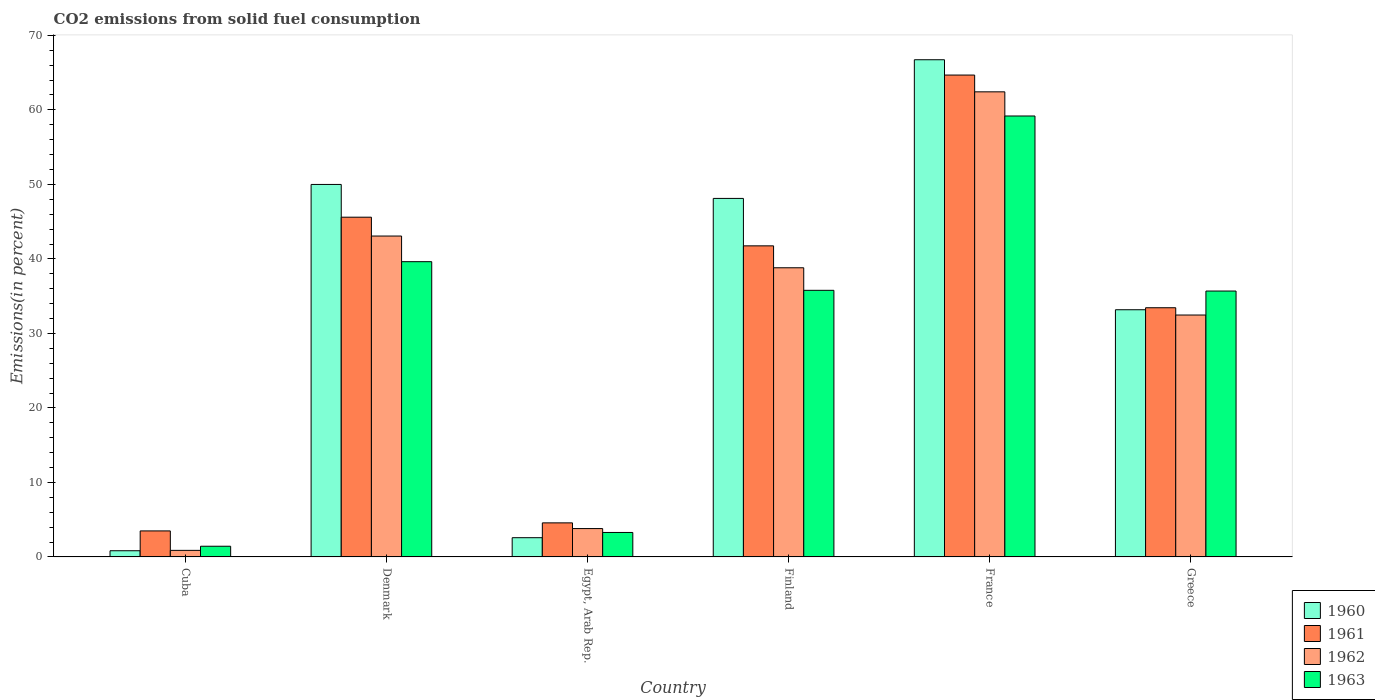How many different coloured bars are there?
Provide a succinct answer. 4. Are the number of bars on each tick of the X-axis equal?
Your response must be concise. Yes. How many bars are there on the 6th tick from the right?
Your answer should be compact. 4. What is the label of the 2nd group of bars from the left?
Your answer should be compact. Denmark. What is the total CO2 emitted in 1962 in Finland?
Make the answer very short. 38.81. Across all countries, what is the maximum total CO2 emitted in 1961?
Keep it short and to the point. 64.68. Across all countries, what is the minimum total CO2 emitted in 1961?
Provide a short and direct response. 3.49. In which country was the total CO2 emitted in 1961 maximum?
Give a very brief answer. France. In which country was the total CO2 emitted in 1963 minimum?
Your response must be concise. Cuba. What is the total total CO2 emitted in 1961 in the graph?
Keep it short and to the point. 193.53. What is the difference between the total CO2 emitted in 1960 in Finland and that in France?
Give a very brief answer. -18.61. What is the difference between the total CO2 emitted in 1963 in France and the total CO2 emitted in 1960 in Finland?
Ensure brevity in your answer.  11.06. What is the average total CO2 emitted in 1963 per country?
Give a very brief answer. 29.17. What is the difference between the total CO2 emitted of/in 1960 and total CO2 emitted of/in 1963 in Egypt, Arab Rep.?
Your answer should be very brief. -0.7. In how many countries, is the total CO2 emitted in 1963 greater than 44 %?
Give a very brief answer. 1. What is the ratio of the total CO2 emitted in 1961 in Cuba to that in Finland?
Your response must be concise. 0.08. What is the difference between the highest and the second highest total CO2 emitted in 1963?
Provide a short and direct response. -23.4. What is the difference between the highest and the lowest total CO2 emitted in 1962?
Offer a terse response. 61.54. In how many countries, is the total CO2 emitted in 1960 greater than the average total CO2 emitted in 1960 taken over all countries?
Ensure brevity in your answer.  3. Is the sum of the total CO2 emitted in 1963 in Finland and France greater than the maximum total CO2 emitted in 1960 across all countries?
Make the answer very short. Yes. How many bars are there?
Keep it short and to the point. 24. Does the graph contain any zero values?
Keep it short and to the point. No. Does the graph contain grids?
Offer a terse response. No. How many legend labels are there?
Your response must be concise. 4. How are the legend labels stacked?
Offer a terse response. Vertical. What is the title of the graph?
Provide a succinct answer. CO2 emissions from solid fuel consumption. Does "1964" appear as one of the legend labels in the graph?
Your answer should be very brief. No. What is the label or title of the Y-axis?
Give a very brief answer. Emissions(in percent). What is the Emissions(in percent) in 1960 in Cuba?
Ensure brevity in your answer.  0.83. What is the Emissions(in percent) of 1961 in Cuba?
Provide a succinct answer. 3.49. What is the Emissions(in percent) of 1962 in Cuba?
Keep it short and to the point. 0.88. What is the Emissions(in percent) in 1963 in Cuba?
Your answer should be compact. 1.43. What is the Emissions(in percent) in 1960 in Denmark?
Your answer should be compact. 49.99. What is the Emissions(in percent) of 1961 in Denmark?
Give a very brief answer. 45.6. What is the Emissions(in percent) in 1962 in Denmark?
Ensure brevity in your answer.  43.07. What is the Emissions(in percent) in 1963 in Denmark?
Your answer should be compact. 39.63. What is the Emissions(in percent) in 1960 in Egypt, Arab Rep.?
Give a very brief answer. 2.58. What is the Emissions(in percent) of 1961 in Egypt, Arab Rep.?
Offer a terse response. 4.57. What is the Emissions(in percent) in 1962 in Egypt, Arab Rep.?
Give a very brief answer. 3.81. What is the Emissions(in percent) in 1963 in Egypt, Arab Rep.?
Offer a terse response. 3.28. What is the Emissions(in percent) of 1960 in Finland?
Give a very brief answer. 48.12. What is the Emissions(in percent) of 1961 in Finland?
Make the answer very short. 41.75. What is the Emissions(in percent) of 1962 in Finland?
Offer a terse response. 38.81. What is the Emissions(in percent) in 1963 in Finland?
Give a very brief answer. 35.78. What is the Emissions(in percent) of 1960 in France?
Provide a short and direct response. 66.73. What is the Emissions(in percent) of 1961 in France?
Keep it short and to the point. 64.68. What is the Emissions(in percent) in 1962 in France?
Offer a very short reply. 62.42. What is the Emissions(in percent) in 1963 in France?
Provide a succinct answer. 59.18. What is the Emissions(in percent) in 1960 in Greece?
Provide a short and direct response. 33.18. What is the Emissions(in percent) in 1961 in Greece?
Provide a succinct answer. 33.45. What is the Emissions(in percent) in 1962 in Greece?
Offer a very short reply. 32.47. What is the Emissions(in percent) of 1963 in Greece?
Provide a short and direct response. 35.69. Across all countries, what is the maximum Emissions(in percent) of 1960?
Give a very brief answer. 66.73. Across all countries, what is the maximum Emissions(in percent) of 1961?
Offer a very short reply. 64.68. Across all countries, what is the maximum Emissions(in percent) of 1962?
Provide a succinct answer. 62.42. Across all countries, what is the maximum Emissions(in percent) of 1963?
Provide a succinct answer. 59.18. Across all countries, what is the minimum Emissions(in percent) in 1960?
Make the answer very short. 0.83. Across all countries, what is the minimum Emissions(in percent) in 1961?
Make the answer very short. 3.49. Across all countries, what is the minimum Emissions(in percent) of 1962?
Offer a terse response. 0.88. Across all countries, what is the minimum Emissions(in percent) of 1963?
Ensure brevity in your answer.  1.43. What is the total Emissions(in percent) of 1960 in the graph?
Make the answer very short. 201.43. What is the total Emissions(in percent) of 1961 in the graph?
Keep it short and to the point. 193.53. What is the total Emissions(in percent) in 1962 in the graph?
Your answer should be very brief. 181.45. What is the total Emissions(in percent) in 1963 in the graph?
Ensure brevity in your answer.  175. What is the difference between the Emissions(in percent) of 1960 in Cuba and that in Denmark?
Give a very brief answer. -49.16. What is the difference between the Emissions(in percent) in 1961 in Cuba and that in Denmark?
Your answer should be compact. -42.11. What is the difference between the Emissions(in percent) in 1962 in Cuba and that in Denmark?
Ensure brevity in your answer.  -42.19. What is the difference between the Emissions(in percent) in 1963 in Cuba and that in Denmark?
Your answer should be compact. -38.19. What is the difference between the Emissions(in percent) of 1960 in Cuba and that in Egypt, Arab Rep.?
Offer a very short reply. -1.75. What is the difference between the Emissions(in percent) in 1961 in Cuba and that in Egypt, Arab Rep.?
Keep it short and to the point. -1.08. What is the difference between the Emissions(in percent) of 1962 in Cuba and that in Egypt, Arab Rep.?
Give a very brief answer. -2.93. What is the difference between the Emissions(in percent) in 1963 in Cuba and that in Egypt, Arab Rep.?
Offer a terse response. -1.85. What is the difference between the Emissions(in percent) in 1960 in Cuba and that in Finland?
Provide a short and direct response. -47.29. What is the difference between the Emissions(in percent) of 1961 in Cuba and that in Finland?
Your answer should be compact. -38.26. What is the difference between the Emissions(in percent) in 1962 in Cuba and that in Finland?
Your answer should be very brief. -37.93. What is the difference between the Emissions(in percent) in 1963 in Cuba and that in Finland?
Offer a very short reply. -34.35. What is the difference between the Emissions(in percent) in 1960 in Cuba and that in France?
Your response must be concise. -65.9. What is the difference between the Emissions(in percent) of 1961 in Cuba and that in France?
Ensure brevity in your answer.  -61.18. What is the difference between the Emissions(in percent) of 1962 in Cuba and that in France?
Ensure brevity in your answer.  -61.54. What is the difference between the Emissions(in percent) in 1963 in Cuba and that in France?
Ensure brevity in your answer.  -57.75. What is the difference between the Emissions(in percent) in 1960 in Cuba and that in Greece?
Ensure brevity in your answer.  -32.35. What is the difference between the Emissions(in percent) in 1961 in Cuba and that in Greece?
Make the answer very short. -29.95. What is the difference between the Emissions(in percent) of 1962 in Cuba and that in Greece?
Offer a terse response. -31.59. What is the difference between the Emissions(in percent) in 1963 in Cuba and that in Greece?
Provide a short and direct response. -34.25. What is the difference between the Emissions(in percent) in 1960 in Denmark and that in Egypt, Arab Rep.?
Keep it short and to the point. 47.41. What is the difference between the Emissions(in percent) of 1961 in Denmark and that in Egypt, Arab Rep.?
Give a very brief answer. 41.03. What is the difference between the Emissions(in percent) of 1962 in Denmark and that in Egypt, Arab Rep.?
Your answer should be compact. 39.26. What is the difference between the Emissions(in percent) in 1963 in Denmark and that in Egypt, Arab Rep.?
Keep it short and to the point. 36.34. What is the difference between the Emissions(in percent) in 1960 in Denmark and that in Finland?
Give a very brief answer. 1.88. What is the difference between the Emissions(in percent) in 1961 in Denmark and that in Finland?
Your answer should be very brief. 3.84. What is the difference between the Emissions(in percent) of 1962 in Denmark and that in Finland?
Your response must be concise. 4.26. What is the difference between the Emissions(in percent) of 1963 in Denmark and that in Finland?
Your response must be concise. 3.84. What is the difference between the Emissions(in percent) of 1960 in Denmark and that in France?
Your answer should be compact. -16.74. What is the difference between the Emissions(in percent) in 1961 in Denmark and that in France?
Your response must be concise. -19.08. What is the difference between the Emissions(in percent) of 1962 in Denmark and that in France?
Offer a terse response. -19.35. What is the difference between the Emissions(in percent) of 1963 in Denmark and that in France?
Your response must be concise. -19.55. What is the difference between the Emissions(in percent) of 1960 in Denmark and that in Greece?
Offer a terse response. 16.82. What is the difference between the Emissions(in percent) of 1961 in Denmark and that in Greece?
Your response must be concise. 12.15. What is the difference between the Emissions(in percent) in 1962 in Denmark and that in Greece?
Offer a very short reply. 10.6. What is the difference between the Emissions(in percent) of 1963 in Denmark and that in Greece?
Your answer should be compact. 3.94. What is the difference between the Emissions(in percent) of 1960 in Egypt, Arab Rep. and that in Finland?
Make the answer very short. -45.54. What is the difference between the Emissions(in percent) of 1961 in Egypt, Arab Rep. and that in Finland?
Offer a very short reply. -37.18. What is the difference between the Emissions(in percent) in 1962 in Egypt, Arab Rep. and that in Finland?
Your answer should be very brief. -35. What is the difference between the Emissions(in percent) of 1963 in Egypt, Arab Rep. and that in Finland?
Your response must be concise. -32.5. What is the difference between the Emissions(in percent) of 1960 in Egypt, Arab Rep. and that in France?
Give a very brief answer. -64.15. What is the difference between the Emissions(in percent) of 1961 in Egypt, Arab Rep. and that in France?
Ensure brevity in your answer.  -60.11. What is the difference between the Emissions(in percent) in 1962 in Egypt, Arab Rep. and that in France?
Offer a terse response. -58.62. What is the difference between the Emissions(in percent) of 1963 in Egypt, Arab Rep. and that in France?
Provide a succinct answer. -55.9. What is the difference between the Emissions(in percent) of 1960 in Egypt, Arab Rep. and that in Greece?
Offer a terse response. -30.6. What is the difference between the Emissions(in percent) of 1961 in Egypt, Arab Rep. and that in Greece?
Make the answer very short. -28.87. What is the difference between the Emissions(in percent) of 1962 in Egypt, Arab Rep. and that in Greece?
Keep it short and to the point. -28.66. What is the difference between the Emissions(in percent) of 1963 in Egypt, Arab Rep. and that in Greece?
Your answer should be compact. -32.4. What is the difference between the Emissions(in percent) of 1960 in Finland and that in France?
Ensure brevity in your answer.  -18.61. What is the difference between the Emissions(in percent) in 1961 in Finland and that in France?
Ensure brevity in your answer.  -22.92. What is the difference between the Emissions(in percent) of 1962 in Finland and that in France?
Provide a succinct answer. -23.61. What is the difference between the Emissions(in percent) in 1963 in Finland and that in France?
Your answer should be very brief. -23.4. What is the difference between the Emissions(in percent) of 1960 in Finland and that in Greece?
Offer a terse response. 14.94. What is the difference between the Emissions(in percent) in 1961 in Finland and that in Greece?
Offer a very short reply. 8.31. What is the difference between the Emissions(in percent) in 1962 in Finland and that in Greece?
Offer a terse response. 6.34. What is the difference between the Emissions(in percent) in 1963 in Finland and that in Greece?
Provide a succinct answer. 0.1. What is the difference between the Emissions(in percent) in 1960 in France and that in Greece?
Offer a terse response. 33.55. What is the difference between the Emissions(in percent) of 1961 in France and that in Greece?
Offer a terse response. 31.23. What is the difference between the Emissions(in percent) in 1962 in France and that in Greece?
Make the answer very short. 29.95. What is the difference between the Emissions(in percent) in 1963 in France and that in Greece?
Ensure brevity in your answer.  23.49. What is the difference between the Emissions(in percent) of 1960 in Cuba and the Emissions(in percent) of 1961 in Denmark?
Offer a terse response. -44.77. What is the difference between the Emissions(in percent) of 1960 in Cuba and the Emissions(in percent) of 1962 in Denmark?
Provide a short and direct response. -42.24. What is the difference between the Emissions(in percent) of 1960 in Cuba and the Emissions(in percent) of 1963 in Denmark?
Give a very brief answer. -38.8. What is the difference between the Emissions(in percent) of 1961 in Cuba and the Emissions(in percent) of 1962 in Denmark?
Your answer should be very brief. -39.58. What is the difference between the Emissions(in percent) of 1961 in Cuba and the Emissions(in percent) of 1963 in Denmark?
Provide a succinct answer. -36.14. What is the difference between the Emissions(in percent) of 1962 in Cuba and the Emissions(in percent) of 1963 in Denmark?
Your response must be concise. -38.75. What is the difference between the Emissions(in percent) of 1960 in Cuba and the Emissions(in percent) of 1961 in Egypt, Arab Rep.?
Keep it short and to the point. -3.74. What is the difference between the Emissions(in percent) of 1960 in Cuba and the Emissions(in percent) of 1962 in Egypt, Arab Rep.?
Offer a very short reply. -2.98. What is the difference between the Emissions(in percent) of 1960 in Cuba and the Emissions(in percent) of 1963 in Egypt, Arab Rep.?
Your answer should be compact. -2.45. What is the difference between the Emissions(in percent) in 1961 in Cuba and the Emissions(in percent) in 1962 in Egypt, Arab Rep.?
Give a very brief answer. -0.31. What is the difference between the Emissions(in percent) in 1961 in Cuba and the Emissions(in percent) in 1963 in Egypt, Arab Rep.?
Provide a short and direct response. 0.21. What is the difference between the Emissions(in percent) of 1962 in Cuba and the Emissions(in percent) of 1963 in Egypt, Arab Rep.?
Ensure brevity in your answer.  -2.4. What is the difference between the Emissions(in percent) of 1960 in Cuba and the Emissions(in percent) of 1961 in Finland?
Provide a short and direct response. -40.92. What is the difference between the Emissions(in percent) in 1960 in Cuba and the Emissions(in percent) in 1962 in Finland?
Offer a terse response. -37.98. What is the difference between the Emissions(in percent) in 1960 in Cuba and the Emissions(in percent) in 1963 in Finland?
Your answer should be compact. -34.95. What is the difference between the Emissions(in percent) in 1961 in Cuba and the Emissions(in percent) in 1962 in Finland?
Ensure brevity in your answer.  -35.32. What is the difference between the Emissions(in percent) of 1961 in Cuba and the Emissions(in percent) of 1963 in Finland?
Give a very brief answer. -32.29. What is the difference between the Emissions(in percent) in 1962 in Cuba and the Emissions(in percent) in 1963 in Finland?
Your answer should be very brief. -34.9. What is the difference between the Emissions(in percent) in 1960 in Cuba and the Emissions(in percent) in 1961 in France?
Make the answer very short. -63.85. What is the difference between the Emissions(in percent) in 1960 in Cuba and the Emissions(in percent) in 1962 in France?
Offer a terse response. -61.59. What is the difference between the Emissions(in percent) in 1960 in Cuba and the Emissions(in percent) in 1963 in France?
Make the answer very short. -58.35. What is the difference between the Emissions(in percent) of 1961 in Cuba and the Emissions(in percent) of 1962 in France?
Your response must be concise. -58.93. What is the difference between the Emissions(in percent) in 1961 in Cuba and the Emissions(in percent) in 1963 in France?
Your answer should be very brief. -55.69. What is the difference between the Emissions(in percent) in 1962 in Cuba and the Emissions(in percent) in 1963 in France?
Your answer should be very brief. -58.3. What is the difference between the Emissions(in percent) in 1960 in Cuba and the Emissions(in percent) in 1961 in Greece?
Keep it short and to the point. -32.62. What is the difference between the Emissions(in percent) of 1960 in Cuba and the Emissions(in percent) of 1962 in Greece?
Offer a very short reply. -31.64. What is the difference between the Emissions(in percent) of 1960 in Cuba and the Emissions(in percent) of 1963 in Greece?
Your answer should be compact. -34.86. What is the difference between the Emissions(in percent) in 1961 in Cuba and the Emissions(in percent) in 1962 in Greece?
Offer a very short reply. -28.98. What is the difference between the Emissions(in percent) in 1961 in Cuba and the Emissions(in percent) in 1963 in Greece?
Your answer should be compact. -32.19. What is the difference between the Emissions(in percent) in 1962 in Cuba and the Emissions(in percent) in 1963 in Greece?
Keep it short and to the point. -34.81. What is the difference between the Emissions(in percent) in 1960 in Denmark and the Emissions(in percent) in 1961 in Egypt, Arab Rep.?
Offer a very short reply. 45.42. What is the difference between the Emissions(in percent) of 1960 in Denmark and the Emissions(in percent) of 1962 in Egypt, Arab Rep.?
Offer a terse response. 46.19. What is the difference between the Emissions(in percent) in 1960 in Denmark and the Emissions(in percent) in 1963 in Egypt, Arab Rep.?
Provide a short and direct response. 46.71. What is the difference between the Emissions(in percent) in 1961 in Denmark and the Emissions(in percent) in 1962 in Egypt, Arab Rep.?
Give a very brief answer. 41.79. What is the difference between the Emissions(in percent) in 1961 in Denmark and the Emissions(in percent) in 1963 in Egypt, Arab Rep.?
Ensure brevity in your answer.  42.31. What is the difference between the Emissions(in percent) of 1962 in Denmark and the Emissions(in percent) of 1963 in Egypt, Arab Rep.?
Offer a terse response. 39.79. What is the difference between the Emissions(in percent) in 1960 in Denmark and the Emissions(in percent) in 1961 in Finland?
Offer a very short reply. 8.24. What is the difference between the Emissions(in percent) in 1960 in Denmark and the Emissions(in percent) in 1962 in Finland?
Your answer should be very brief. 11.18. What is the difference between the Emissions(in percent) in 1960 in Denmark and the Emissions(in percent) in 1963 in Finland?
Offer a very short reply. 14.21. What is the difference between the Emissions(in percent) of 1961 in Denmark and the Emissions(in percent) of 1962 in Finland?
Provide a succinct answer. 6.79. What is the difference between the Emissions(in percent) in 1961 in Denmark and the Emissions(in percent) in 1963 in Finland?
Your answer should be compact. 9.81. What is the difference between the Emissions(in percent) of 1962 in Denmark and the Emissions(in percent) of 1963 in Finland?
Your response must be concise. 7.29. What is the difference between the Emissions(in percent) of 1960 in Denmark and the Emissions(in percent) of 1961 in France?
Ensure brevity in your answer.  -14.68. What is the difference between the Emissions(in percent) of 1960 in Denmark and the Emissions(in percent) of 1962 in France?
Your response must be concise. -12.43. What is the difference between the Emissions(in percent) of 1960 in Denmark and the Emissions(in percent) of 1963 in France?
Ensure brevity in your answer.  -9.19. What is the difference between the Emissions(in percent) of 1961 in Denmark and the Emissions(in percent) of 1962 in France?
Provide a succinct answer. -16.82. What is the difference between the Emissions(in percent) in 1961 in Denmark and the Emissions(in percent) in 1963 in France?
Keep it short and to the point. -13.58. What is the difference between the Emissions(in percent) in 1962 in Denmark and the Emissions(in percent) in 1963 in France?
Provide a short and direct response. -16.11. What is the difference between the Emissions(in percent) of 1960 in Denmark and the Emissions(in percent) of 1961 in Greece?
Offer a very short reply. 16.55. What is the difference between the Emissions(in percent) in 1960 in Denmark and the Emissions(in percent) in 1962 in Greece?
Ensure brevity in your answer.  17.53. What is the difference between the Emissions(in percent) of 1960 in Denmark and the Emissions(in percent) of 1963 in Greece?
Your response must be concise. 14.31. What is the difference between the Emissions(in percent) in 1961 in Denmark and the Emissions(in percent) in 1962 in Greece?
Your answer should be compact. 13.13. What is the difference between the Emissions(in percent) of 1961 in Denmark and the Emissions(in percent) of 1963 in Greece?
Ensure brevity in your answer.  9.91. What is the difference between the Emissions(in percent) of 1962 in Denmark and the Emissions(in percent) of 1963 in Greece?
Offer a very short reply. 7.38. What is the difference between the Emissions(in percent) in 1960 in Egypt, Arab Rep. and the Emissions(in percent) in 1961 in Finland?
Make the answer very short. -39.17. What is the difference between the Emissions(in percent) in 1960 in Egypt, Arab Rep. and the Emissions(in percent) in 1962 in Finland?
Give a very brief answer. -36.23. What is the difference between the Emissions(in percent) in 1960 in Egypt, Arab Rep. and the Emissions(in percent) in 1963 in Finland?
Provide a succinct answer. -33.2. What is the difference between the Emissions(in percent) in 1961 in Egypt, Arab Rep. and the Emissions(in percent) in 1962 in Finland?
Ensure brevity in your answer.  -34.24. What is the difference between the Emissions(in percent) of 1961 in Egypt, Arab Rep. and the Emissions(in percent) of 1963 in Finland?
Provide a succinct answer. -31.21. What is the difference between the Emissions(in percent) in 1962 in Egypt, Arab Rep. and the Emissions(in percent) in 1963 in Finland?
Offer a terse response. -31.98. What is the difference between the Emissions(in percent) in 1960 in Egypt, Arab Rep. and the Emissions(in percent) in 1961 in France?
Your answer should be very brief. -62.09. What is the difference between the Emissions(in percent) of 1960 in Egypt, Arab Rep. and the Emissions(in percent) of 1962 in France?
Offer a very short reply. -59.84. What is the difference between the Emissions(in percent) of 1960 in Egypt, Arab Rep. and the Emissions(in percent) of 1963 in France?
Your answer should be compact. -56.6. What is the difference between the Emissions(in percent) of 1961 in Egypt, Arab Rep. and the Emissions(in percent) of 1962 in France?
Keep it short and to the point. -57.85. What is the difference between the Emissions(in percent) in 1961 in Egypt, Arab Rep. and the Emissions(in percent) in 1963 in France?
Give a very brief answer. -54.61. What is the difference between the Emissions(in percent) in 1962 in Egypt, Arab Rep. and the Emissions(in percent) in 1963 in France?
Provide a short and direct response. -55.38. What is the difference between the Emissions(in percent) in 1960 in Egypt, Arab Rep. and the Emissions(in percent) in 1961 in Greece?
Offer a very short reply. -30.86. What is the difference between the Emissions(in percent) in 1960 in Egypt, Arab Rep. and the Emissions(in percent) in 1962 in Greece?
Your answer should be very brief. -29.89. What is the difference between the Emissions(in percent) of 1960 in Egypt, Arab Rep. and the Emissions(in percent) of 1963 in Greece?
Your answer should be very brief. -33.11. What is the difference between the Emissions(in percent) in 1961 in Egypt, Arab Rep. and the Emissions(in percent) in 1962 in Greece?
Give a very brief answer. -27.9. What is the difference between the Emissions(in percent) of 1961 in Egypt, Arab Rep. and the Emissions(in percent) of 1963 in Greece?
Keep it short and to the point. -31.12. What is the difference between the Emissions(in percent) of 1962 in Egypt, Arab Rep. and the Emissions(in percent) of 1963 in Greece?
Your answer should be compact. -31.88. What is the difference between the Emissions(in percent) of 1960 in Finland and the Emissions(in percent) of 1961 in France?
Offer a very short reply. -16.56. What is the difference between the Emissions(in percent) in 1960 in Finland and the Emissions(in percent) in 1962 in France?
Offer a terse response. -14.3. What is the difference between the Emissions(in percent) of 1960 in Finland and the Emissions(in percent) of 1963 in France?
Your response must be concise. -11.06. What is the difference between the Emissions(in percent) in 1961 in Finland and the Emissions(in percent) in 1962 in France?
Make the answer very short. -20.67. What is the difference between the Emissions(in percent) in 1961 in Finland and the Emissions(in percent) in 1963 in France?
Make the answer very short. -17.43. What is the difference between the Emissions(in percent) in 1962 in Finland and the Emissions(in percent) in 1963 in France?
Make the answer very short. -20.37. What is the difference between the Emissions(in percent) in 1960 in Finland and the Emissions(in percent) in 1961 in Greece?
Your answer should be very brief. 14.67. What is the difference between the Emissions(in percent) of 1960 in Finland and the Emissions(in percent) of 1962 in Greece?
Make the answer very short. 15.65. What is the difference between the Emissions(in percent) of 1960 in Finland and the Emissions(in percent) of 1963 in Greece?
Give a very brief answer. 12.43. What is the difference between the Emissions(in percent) in 1961 in Finland and the Emissions(in percent) in 1962 in Greece?
Provide a succinct answer. 9.29. What is the difference between the Emissions(in percent) in 1961 in Finland and the Emissions(in percent) in 1963 in Greece?
Ensure brevity in your answer.  6.07. What is the difference between the Emissions(in percent) of 1962 in Finland and the Emissions(in percent) of 1963 in Greece?
Offer a terse response. 3.12. What is the difference between the Emissions(in percent) of 1960 in France and the Emissions(in percent) of 1961 in Greece?
Your answer should be very brief. 33.29. What is the difference between the Emissions(in percent) in 1960 in France and the Emissions(in percent) in 1962 in Greece?
Make the answer very short. 34.26. What is the difference between the Emissions(in percent) in 1960 in France and the Emissions(in percent) in 1963 in Greece?
Offer a terse response. 31.05. What is the difference between the Emissions(in percent) in 1961 in France and the Emissions(in percent) in 1962 in Greece?
Offer a terse response. 32.21. What is the difference between the Emissions(in percent) in 1961 in France and the Emissions(in percent) in 1963 in Greece?
Give a very brief answer. 28.99. What is the difference between the Emissions(in percent) in 1962 in France and the Emissions(in percent) in 1963 in Greece?
Your answer should be compact. 26.74. What is the average Emissions(in percent) in 1960 per country?
Offer a very short reply. 33.57. What is the average Emissions(in percent) in 1961 per country?
Make the answer very short. 32.26. What is the average Emissions(in percent) in 1962 per country?
Ensure brevity in your answer.  30.24. What is the average Emissions(in percent) of 1963 per country?
Your answer should be compact. 29.17. What is the difference between the Emissions(in percent) in 1960 and Emissions(in percent) in 1961 in Cuba?
Your response must be concise. -2.66. What is the difference between the Emissions(in percent) in 1960 and Emissions(in percent) in 1962 in Cuba?
Offer a terse response. -0.05. What is the difference between the Emissions(in percent) in 1960 and Emissions(in percent) in 1963 in Cuba?
Provide a short and direct response. -0.6. What is the difference between the Emissions(in percent) of 1961 and Emissions(in percent) of 1962 in Cuba?
Your response must be concise. 2.61. What is the difference between the Emissions(in percent) of 1961 and Emissions(in percent) of 1963 in Cuba?
Offer a very short reply. 2.06. What is the difference between the Emissions(in percent) of 1962 and Emissions(in percent) of 1963 in Cuba?
Make the answer very short. -0.55. What is the difference between the Emissions(in percent) of 1960 and Emissions(in percent) of 1961 in Denmark?
Provide a succinct answer. 4.4. What is the difference between the Emissions(in percent) of 1960 and Emissions(in percent) of 1962 in Denmark?
Keep it short and to the point. 6.93. What is the difference between the Emissions(in percent) in 1960 and Emissions(in percent) in 1963 in Denmark?
Offer a terse response. 10.37. What is the difference between the Emissions(in percent) in 1961 and Emissions(in percent) in 1962 in Denmark?
Your answer should be compact. 2.53. What is the difference between the Emissions(in percent) of 1961 and Emissions(in percent) of 1963 in Denmark?
Your answer should be compact. 5.97. What is the difference between the Emissions(in percent) in 1962 and Emissions(in percent) in 1963 in Denmark?
Ensure brevity in your answer.  3.44. What is the difference between the Emissions(in percent) in 1960 and Emissions(in percent) in 1961 in Egypt, Arab Rep.?
Your answer should be very brief. -1.99. What is the difference between the Emissions(in percent) of 1960 and Emissions(in percent) of 1962 in Egypt, Arab Rep.?
Keep it short and to the point. -1.22. What is the difference between the Emissions(in percent) of 1960 and Emissions(in percent) of 1963 in Egypt, Arab Rep.?
Give a very brief answer. -0.7. What is the difference between the Emissions(in percent) in 1961 and Emissions(in percent) in 1962 in Egypt, Arab Rep.?
Offer a terse response. 0.76. What is the difference between the Emissions(in percent) in 1961 and Emissions(in percent) in 1963 in Egypt, Arab Rep.?
Provide a short and direct response. 1.29. What is the difference between the Emissions(in percent) in 1962 and Emissions(in percent) in 1963 in Egypt, Arab Rep.?
Your answer should be compact. 0.52. What is the difference between the Emissions(in percent) in 1960 and Emissions(in percent) in 1961 in Finland?
Offer a very short reply. 6.37. What is the difference between the Emissions(in percent) of 1960 and Emissions(in percent) of 1962 in Finland?
Your answer should be compact. 9.31. What is the difference between the Emissions(in percent) of 1960 and Emissions(in percent) of 1963 in Finland?
Provide a succinct answer. 12.34. What is the difference between the Emissions(in percent) of 1961 and Emissions(in percent) of 1962 in Finland?
Offer a terse response. 2.94. What is the difference between the Emissions(in percent) in 1961 and Emissions(in percent) in 1963 in Finland?
Ensure brevity in your answer.  5.97. What is the difference between the Emissions(in percent) of 1962 and Emissions(in percent) of 1963 in Finland?
Provide a succinct answer. 3.03. What is the difference between the Emissions(in percent) in 1960 and Emissions(in percent) in 1961 in France?
Give a very brief answer. 2.06. What is the difference between the Emissions(in percent) of 1960 and Emissions(in percent) of 1962 in France?
Offer a terse response. 4.31. What is the difference between the Emissions(in percent) of 1960 and Emissions(in percent) of 1963 in France?
Keep it short and to the point. 7.55. What is the difference between the Emissions(in percent) in 1961 and Emissions(in percent) in 1962 in France?
Keep it short and to the point. 2.25. What is the difference between the Emissions(in percent) of 1961 and Emissions(in percent) of 1963 in France?
Give a very brief answer. 5.49. What is the difference between the Emissions(in percent) in 1962 and Emissions(in percent) in 1963 in France?
Give a very brief answer. 3.24. What is the difference between the Emissions(in percent) in 1960 and Emissions(in percent) in 1961 in Greece?
Offer a very short reply. -0.27. What is the difference between the Emissions(in percent) of 1960 and Emissions(in percent) of 1962 in Greece?
Provide a short and direct response. 0.71. What is the difference between the Emissions(in percent) of 1960 and Emissions(in percent) of 1963 in Greece?
Keep it short and to the point. -2.51. What is the difference between the Emissions(in percent) of 1961 and Emissions(in percent) of 1962 in Greece?
Provide a succinct answer. 0.98. What is the difference between the Emissions(in percent) of 1961 and Emissions(in percent) of 1963 in Greece?
Offer a terse response. -2.24. What is the difference between the Emissions(in percent) in 1962 and Emissions(in percent) in 1963 in Greece?
Your response must be concise. -3.22. What is the ratio of the Emissions(in percent) of 1960 in Cuba to that in Denmark?
Provide a succinct answer. 0.02. What is the ratio of the Emissions(in percent) of 1961 in Cuba to that in Denmark?
Ensure brevity in your answer.  0.08. What is the ratio of the Emissions(in percent) of 1962 in Cuba to that in Denmark?
Your answer should be compact. 0.02. What is the ratio of the Emissions(in percent) of 1963 in Cuba to that in Denmark?
Make the answer very short. 0.04. What is the ratio of the Emissions(in percent) in 1960 in Cuba to that in Egypt, Arab Rep.?
Provide a short and direct response. 0.32. What is the ratio of the Emissions(in percent) of 1961 in Cuba to that in Egypt, Arab Rep.?
Ensure brevity in your answer.  0.76. What is the ratio of the Emissions(in percent) in 1962 in Cuba to that in Egypt, Arab Rep.?
Keep it short and to the point. 0.23. What is the ratio of the Emissions(in percent) in 1963 in Cuba to that in Egypt, Arab Rep.?
Give a very brief answer. 0.44. What is the ratio of the Emissions(in percent) in 1960 in Cuba to that in Finland?
Your answer should be compact. 0.02. What is the ratio of the Emissions(in percent) of 1961 in Cuba to that in Finland?
Your answer should be very brief. 0.08. What is the ratio of the Emissions(in percent) in 1962 in Cuba to that in Finland?
Your answer should be compact. 0.02. What is the ratio of the Emissions(in percent) of 1963 in Cuba to that in Finland?
Ensure brevity in your answer.  0.04. What is the ratio of the Emissions(in percent) of 1960 in Cuba to that in France?
Your answer should be compact. 0.01. What is the ratio of the Emissions(in percent) in 1961 in Cuba to that in France?
Your answer should be compact. 0.05. What is the ratio of the Emissions(in percent) in 1962 in Cuba to that in France?
Offer a terse response. 0.01. What is the ratio of the Emissions(in percent) of 1963 in Cuba to that in France?
Keep it short and to the point. 0.02. What is the ratio of the Emissions(in percent) in 1960 in Cuba to that in Greece?
Your answer should be compact. 0.03. What is the ratio of the Emissions(in percent) in 1961 in Cuba to that in Greece?
Keep it short and to the point. 0.1. What is the ratio of the Emissions(in percent) of 1962 in Cuba to that in Greece?
Offer a very short reply. 0.03. What is the ratio of the Emissions(in percent) in 1963 in Cuba to that in Greece?
Make the answer very short. 0.04. What is the ratio of the Emissions(in percent) in 1960 in Denmark to that in Egypt, Arab Rep.?
Offer a very short reply. 19.37. What is the ratio of the Emissions(in percent) in 1961 in Denmark to that in Egypt, Arab Rep.?
Give a very brief answer. 9.98. What is the ratio of the Emissions(in percent) of 1962 in Denmark to that in Egypt, Arab Rep.?
Offer a terse response. 11.32. What is the ratio of the Emissions(in percent) of 1963 in Denmark to that in Egypt, Arab Rep.?
Offer a very short reply. 12.07. What is the ratio of the Emissions(in percent) in 1960 in Denmark to that in Finland?
Your answer should be very brief. 1.04. What is the ratio of the Emissions(in percent) in 1961 in Denmark to that in Finland?
Your response must be concise. 1.09. What is the ratio of the Emissions(in percent) in 1962 in Denmark to that in Finland?
Provide a succinct answer. 1.11. What is the ratio of the Emissions(in percent) of 1963 in Denmark to that in Finland?
Make the answer very short. 1.11. What is the ratio of the Emissions(in percent) in 1960 in Denmark to that in France?
Offer a very short reply. 0.75. What is the ratio of the Emissions(in percent) of 1961 in Denmark to that in France?
Provide a succinct answer. 0.7. What is the ratio of the Emissions(in percent) in 1962 in Denmark to that in France?
Make the answer very short. 0.69. What is the ratio of the Emissions(in percent) of 1963 in Denmark to that in France?
Keep it short and to the point. 0.67. What is the ratio of the Emissions(in percent) in 1960 in Denmark to that in Greece?
Offer a very short reply. 1.51. What is the ratio of the Emissions(in percent) of 1961 in Denmark to that in Greece?
Provide a succinct answer. 1.36. What is the ratio of the Emissions(in percent) of 1962 in Denmark to that in Greece?
Offer a terse response. 1.33. What is the ratio of the Emissions(in percent) in 1963 in Denmark to that in Greece?
Give a very brief answer. 1.11. What is the ratio of the Emissions(in percent) in 1960 in Egypt, Arab Rep. to that in Finland?
Your response must be concise. 0.05. What is the ratio of the Emissions(in percent) of 1961 in Egypt, Arab Rep. to that in Finland?
Make the answer very short. 0.11. What is the ratio of the Emissions(in percent) of 1962 in Egypt, Arab Rep. to that in Finland?
Offer a very short reply. 0.1. What is the ratio of the Emissions(in percent) of 1963 in Egypt, Arab Rep. to that in Finland?
Ensure brevity in your answer.  0.09. What is the ratio of the Emissions(in percent) of 1960 in Egypt, Arab Rep. to that in France?
Your answer should be compact. 0.04. What is the ratio of the Emissions(in percent) of 1961 in Egypt, Arab Rep. to that in France?
Give a very brief answer. 0.07. What is the ratio of the Emissions(in percent) in 1962 in Egypt, Arab Rep. to that in France?
Keep it short and to the point. 0.06. What is the ratio of the Emissions(in percent) in 1963 in Egypt, Arab Rep. to that in France?
Keep it short and to the point. 0.06. What is the ratio of the Emissions(in percent) of 1960 in Egypt, Arab Rep. to that in Greece?
Your answer should be compact. 0.08. What is the ratio of the Emissions(in percent) of 1961 in Egypt, Arab Rep. to that in Greece?
Your answer should be very brief. 0.14. What is the ratio of the Emissions(in percent) in 1962 in Egypt, Arab Rep. to that in Greece?
Keep it short and to the point. 0.12. What is the ratio of the Emissions(in percent) of 1963 in Egypt, Arab Rep. to that in Greece?
Offer a very short reply. 0.09. What is the ratio of the Emissions(in percent) in 1960 in Finland to that in France?
Offer a terse response. 0.72. What is the ratio of the Emissions(in percent) in 1961 in Finland to that in France?
Your answer should be very brief. 0.65. What is the ratio of the Emissions(in percent) of 1962 in Finland to that in France?
Make the answer very short. 0.62. What is the ratio of the Emissions(in percent) of 1963 in Finland to that in France?
Make the answer very short. 0.6. What is the ratio of the Emissions(in percent) of 1960 in Finland to that in Greece?
Keep it short and to the point. 1.45. What is the ratio of the Emissions(in percent) in 1961 in Finland to that in Greece?
Offer a terse response. 1.25. What is the ratio of the Emissions(in percent) in 1962 in Finland to that in Greece?
Your answer should be compact. 1.2. What is the ratio of the Emissions(in percent) in 1960 in France to that in Greece?
Your answer should be very brief. 2.01. What is the ratio of the Emissions(in percent) of 1961 in France to that in Greece?
Your response must be concise. 1.93. What is the ratio of the Emissions(in percent) of 1962 in France to that in Greece?
Your answer should be very brief. 1.92. What is the ratio of the Emissions(in percent) in 1963 in France to that in Greece?
Offer a terse response. 1.66. What is the difference between the highest and the second highest Emissions(in percent) of 1960?
Give a very brief answer. 16.74. What is the difference between the highest and the second highest Emissions(in percent) in 1961?
Offer a terse response. 19.08. What is the difference between the highest and the second highest Emissions(in percent) of 1962?
Your response must be concise. 19.35. What is the difference between the highest and the second highest Emissions(in percent) of 1963?
Give a very brief answer. 19.55. What is the difference between the highest and the lowest Emissions(in percent) of 1960?
Ensure brevity in your answer.  65.9. What is the difference between the highest and the lowest Emissions(in percent) in 1961?
Your answer should be very brief. 61.18. What is the difference between the highest and the lowest Emissions(in percent) of 1962?
Provide a short and direct response. 61.54. What is the difference between the highest and the lowest Emissions(in percent) in 1963?
Provide a short and direct response. 57.75. 